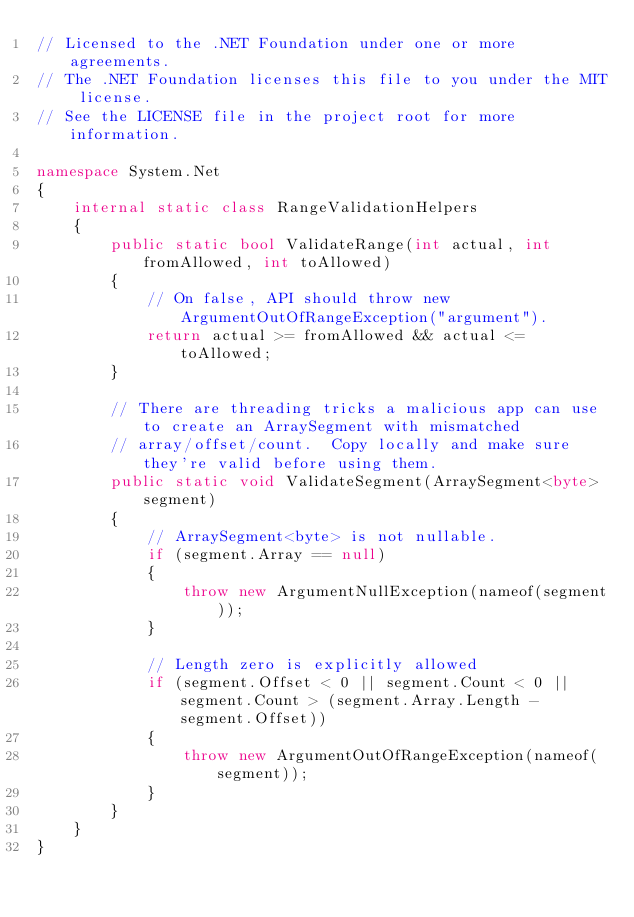<code> <loc_0><loc_0><loc_500><loc_500><_C#_>// Licensed to the .NET Foundation under one or more agreements.
// The .NET Foundation licenses this file to you under the MIT license.
// See the LICENSE file in the project root for more information.

namespace System.Net
{
    internal static class RangeValidationHelpers
    {
        public static bool ValidateRange(int actual, int fromAllowed, int toAllowed)
        {
            // On false, API should throw new ArgumentOutOfRangeException("argument").
            return actual >= fromAllowed && actual <= toAllowed;
        }

        // There are threading tricks a malicious app can use to create an ArraySegment with mismatched
        // array/offset/count.  Copy locally and make sure they're valid before using them.
        public static void ValidateSegment(ArraySegment<byte> segment)
        {
            // ArraySegment<byte> is not nullable.
            if (segment.Array == null)
            {
                throw new ArgumentNullException(nameof(segment));
            }

            // Length zero is explicitly allowed
            if (segment.Offset < 0 || segment.Count < 0 || segment.Count > (segment.Array.Length - segment.Offset))
            {
                throw new ArgumentOutOfRangeException(nameof(segment));
            }
        }
    }
}
</code> 